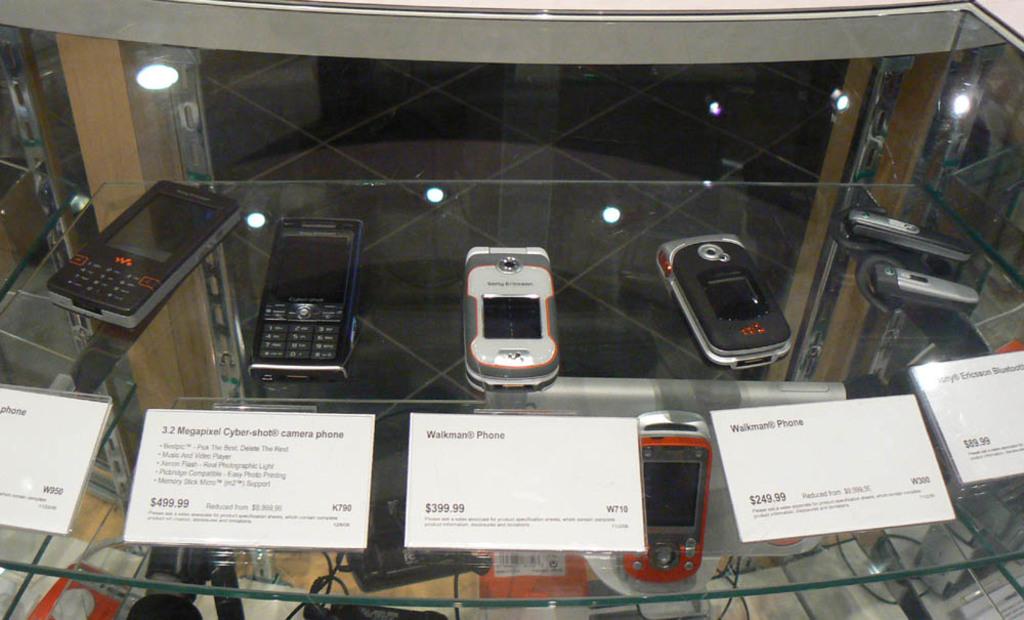What kind of phone is this?
Your response must be concise. Walkman phone. How much is the middle phone?
Your answer should be compact. 399.99. 